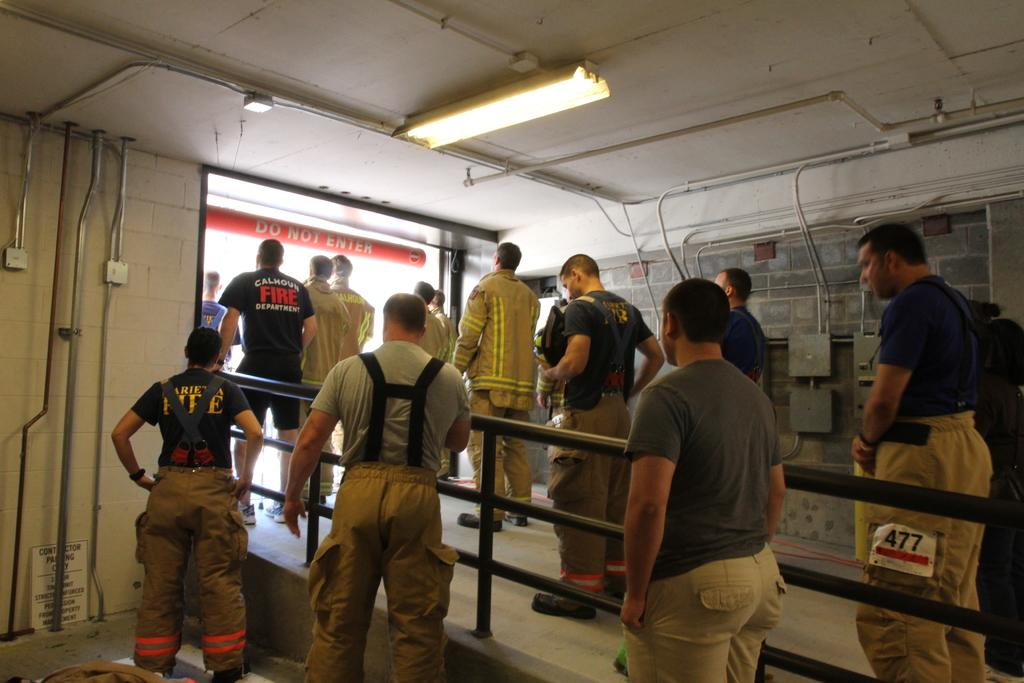How many men are standing on the left side of the image? There are three men standing on the left side of the image. Are there any other men visible in the image? Yes, there are other men standing on the right side of the image. What can be seen at the top of the image? There is a light visible at the top of the image. How does the pump function in the image? There is no pump present in the image. What is the mouth of the man on the right side of the image doing? There is no specific action of the mouth mentioned in the image, as it only shows men standing. 